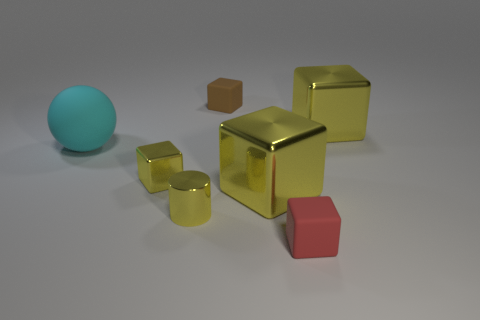What shape is the small object that is the same color as the metallic cylinder? cube 